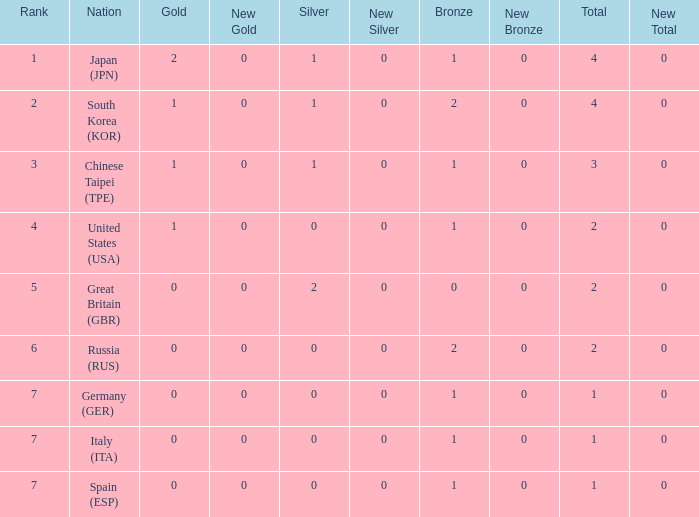How many total medals does a country with more than 1 silver medals have? 2.0. 